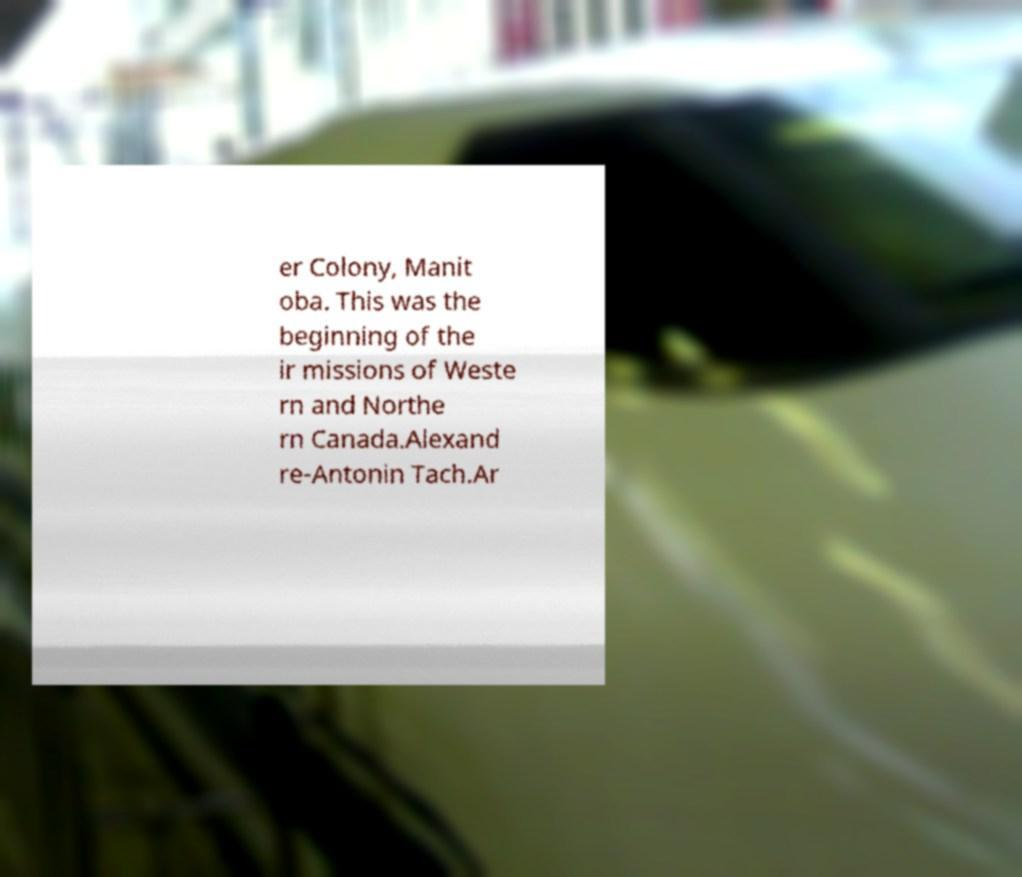Could you assist in decoding the text presented in this image and type it out clearly? er Colony, Manit oba. This was the beginning of the ir missions of Weste rn and Northe rn Canada.Alexand re-Antonin Tach.Ar 